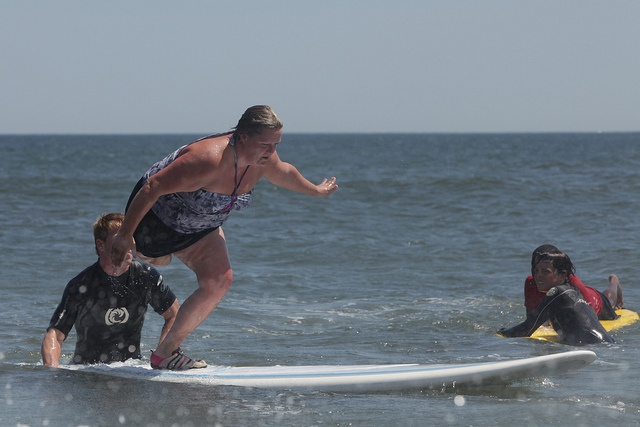Describe the objects in this image and their specific colors. I can see people in darkgray, gray, and black tones, surfboard in darkgray, lightgray, and gray tones, people in darkgray, black, and gray tones, people in darkgray, black, and gray tones, and people in darkgray, black, gray, brown, and maroon tones in this image. 